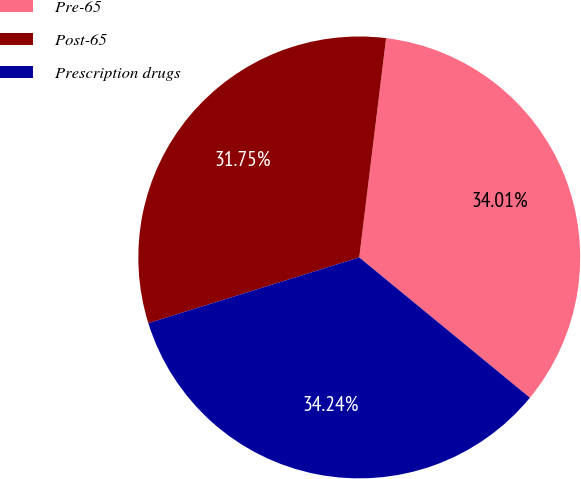Convert chart to OTSL. <chart><loc_0><loc_0><loc_500><loc_500><pie_chart><fcel>Pre-65<fcel>Post-65<fcel>Prescription drugs<nl><fcel>34.01%<fcel>31.75%<fcel>34.24%<nl></chart> 